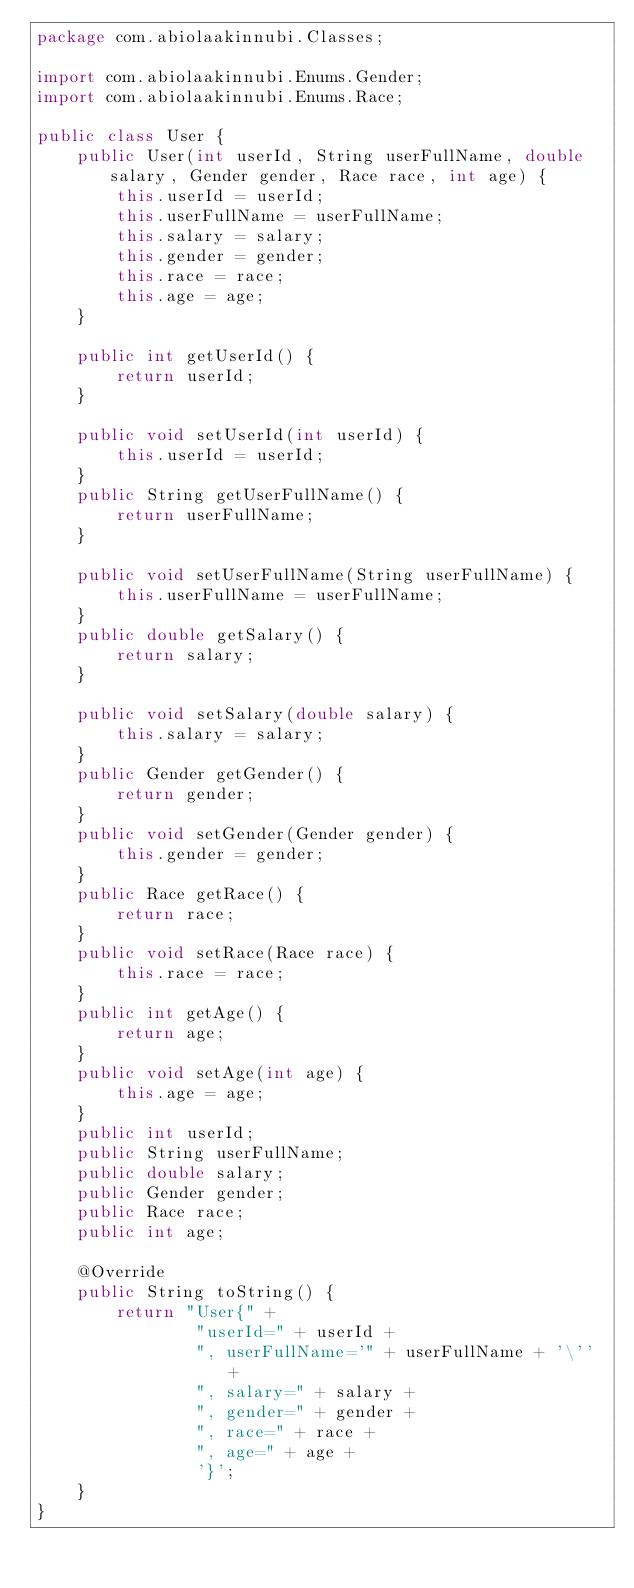Convert code to text. <code><loc_0><loc_0><loc_500><loc_500><_Java_>package com.abiolaakinnubi.Classes;

import com.abiolaakinnubi.Enums.Gender;
import com.abiolaakinnubi.Enums.Race;

public class User {
    public User(int userId, String userFullName, double salary, Gender gender, Race race, int age) {
        this.userId = userId;
        this.userFullName = userFullName;
        this.salary = salary;
        this.gender = gender;
        this.race = race;
        this.age = age;
    }

    public int getUserId() {
        return userId;
    }

    public void setUserId(int userId) {
        this.userId = userId;
    }
    public String getUserFullName() {
        return userFullName;
    }

    public void setUserFullName(String userFullName) {
        this.userFullName = userFullName;
    }
    public double getSalary() {
        return salary;
    }

    public void setSalary(double salary) {
        this.salary = salary;
    }
    public Gender getGender() {
        return gender;
    }
    public void setGender(Gender gender) {
        this.gender = gender;
    }
    public Race getRace() {
        return race;
    }
    public void setRace(Race race) {
        this.race = race;
    }
    public int getAge() {
        return age;
    }
    public void setAge(int age) {
        this.age = age;
    }
    public int userId;
    public String userFullName;
    public double salary;
    public Gender gender;
    public Race race;
    public int age;

    @Override
    public String toString() {
        return "User{" +
                "userId=" + userId +
                ", userFullName='" + userFullName + '\'' +
                ", salary=" + salary +
                ", gender=" + gender +
                ", race=" + race +
                ", age=" + age +
                '}';
    }
}
</code> 